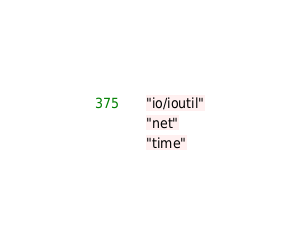<code> <loc_0><loc_0><loc_500><loc_500><_Go_>	"io/ioutil"
	"net"
	"time"
</code> 